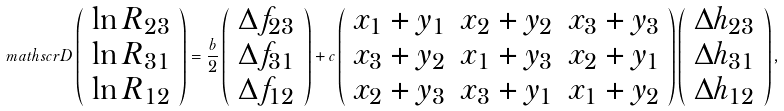<formula> <loc_0><loc_0><loc_500><loc_500>\ m a t h s c r { D } \left ( \begin{array} { c } \ln R _ { 2 3 } \\ \ln R _ { 3 1 } \\ \ln R _ { 1 2 } \end{array} \right ) = \frac { b } { 2 } \left ( \begin{array} { c } \Delta f _ { 2 3 } \\ \Delta f _ { 3 1 } \\ \Delta f _ { 1 2 } \end{array} \right ) + c \left ( \begin{array} { c c l } x _ { 1 } + y _ { 1 } & x _ { 2 } + y _ { 2 } & x _ { 3 } + y _ { 3 } \\ x _ { 3 } + y _ { 2 } & x _ { 1 } + y _ { 3 } & x _ { 2 } + y _ { 1 } \\ x _ { 2 } + y _ { 3 } & x _ { 3 } + y _ { 1 } & x _ { 1 } + y _ { 2 } \end{array} \right ) \left ( \begin{array} { c } \Delta h _ { 2 3 } \\ \Delta h _ { 3 1 } \\ \Delta h _ { 1 2 } \end{array} \right ) ,</formula> 